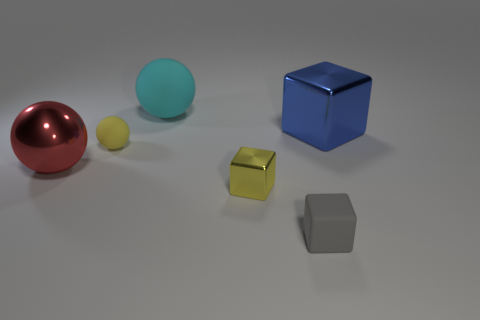Can you describe the lighting in the scene? The lighting in the image has a soft, diffuse quality, possibly from an overhead source. It casts gentle shadows directly beneath the objects, giving each a clear outline without harsh contrasts. How might the lighting affect the colors of the objects? The even lighting helps to bring out the true colors of the objects without creating colored highlights or overly dark shadows that might alter our perception of their colors. 